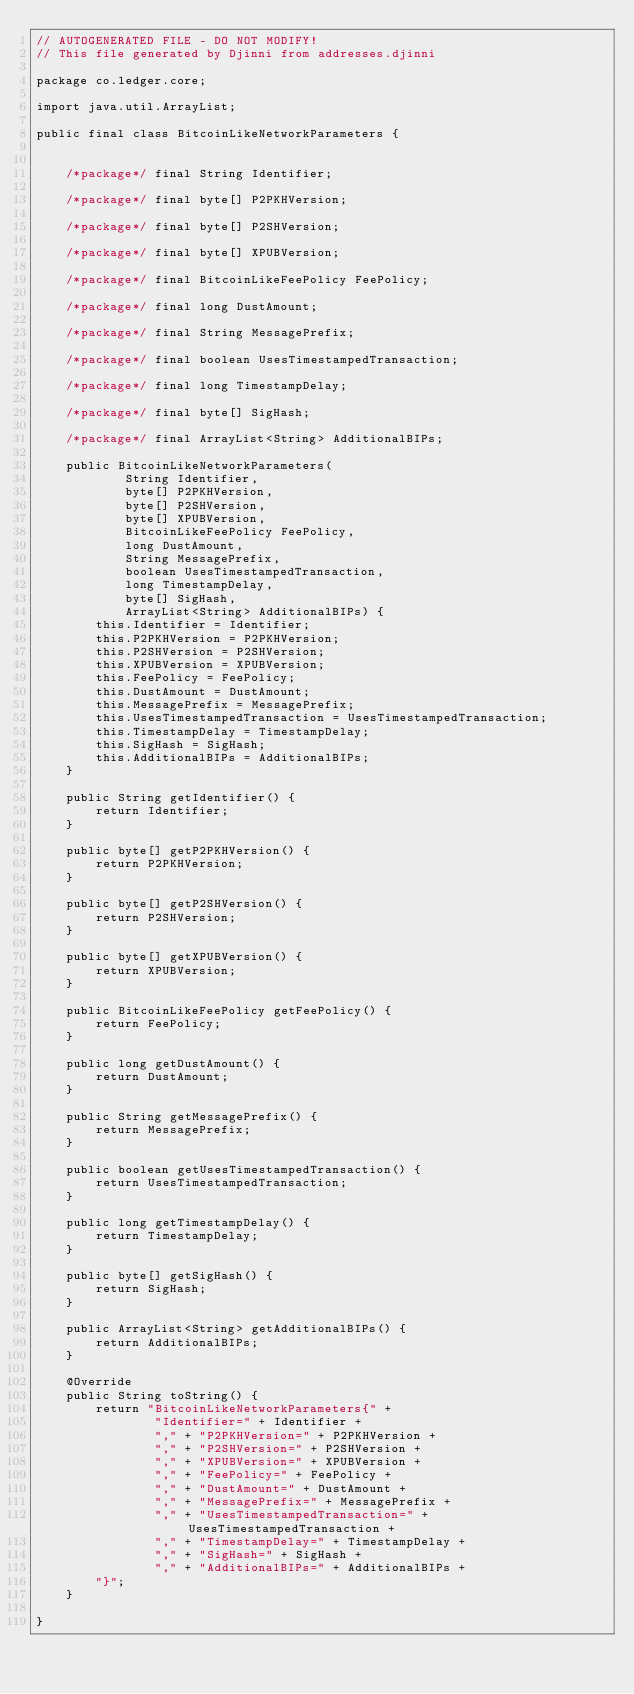Convert code to text. <code><loc_0><loc_0><loc_500><loc_500><_Java_>// AUTOGENERATED FILE - DO NOT MODIFY!
// This file generated by Djinni from addresses.djinni

package co.ledger.core;

import java.util.ArrayList;

public final class BitcoinLikeNetworkParameters {


    /*package*/ final String Identifier;

    /*package*/ final byte[] P2PKHVersion;

    /*package*/ final byte[] P2SHVersion;

    /*package*/ final byte[] XPUBVersion;

    /*package*/ final BitcoinLikeFeePolicy FeePolicy;

    /*package*/ final long DustAmount;

    /*package*/ final String MessagePrefix;

    /*package*/ final boolean UsesTimestampedTransaction;

    /*package*/ final long TimestampDelay;

    /*package*/ final byte[] SigHash;

    /*package*/ final ArrayList<String> AdditionalBIPs;

    public BitcoinLikeNetworkParameters(
            String Identifier,
            byte[] P2PKHVersion,
            byte[] P2SHVersion,
            byte[] XPUBVersion,
            BitcoinLikeFeePolicy FeePolicy,
            long DustAmount,
            String MessagePrefix,
            boolean UsesTimestampedTransaction,
            long TimestampDelay,
            byte[] SigHash,
            ArrayList<String> AdditionalBIPs) {
        this.Identifier = Identifier;
        this.P2PKHVersion = P2PKHVersion;
        this.P2SHVersion = P2SHVersion;
        this.XPUBVersion = XPUBVersion;
        this.FeePolicy = FeePolicy;
        this.DustAmount = DustAmount;
        this.MessagePrefix = MessagePrefix;
        this.UsesTimestampedTransaction = UsesTimestampedTransaction;
        this.TimestampDelay = TimestampDelay;
        this.SigHash = SigHash;
        this.AdditionalBIPs = AdditionalBIPs;
    }

    public String getIdentifier() {
        return Identifier;
    }

    public byte[] getP2PKHVersion() {
        return P2PKHVersion;
    }

    public byte[] getP2SHVersion() {
        return P2SHVersion;
    }

    public byte[] getXPUBVersion() {
        return XPUBVersion;
    }

    public BitcoinLikeFeePolicy getFeePolicy() {
        return FeePolicy;
    }

    public long getDustAmount() {
        return DustAmount;
    }

    public String getMessagePrefix() {
        return MessagePrefix;
    }

    public boolean getUsesTimestampedTransaction() {
        return UsesTimestampedTransaction;
    }

    public long getTimestampDelay() {
        return TimestampDelay;
    }

    public byte[] getSigHash() {
        return SigHash;
    }

    public ArrayList<String> getAdditionalBIPs() {
        return AdditionalBIPs;
    }

    @Override
    public String toString() {
        return "BitcoinLikeNetworkParameters{" +
                "Identifier=" + Identifier +
                "," + "P2PKHVersion=" + P2PKHVersion +
                "," + "P2SHVersion=" + P2SHVersion +
                "," + "XPUBVersion=" + XPUBVersion +
                "," + "FeePolicy=" + FeePolicy +
                "," + "DustAmount=" + DustAmount +
                "," + "MessagePrefix=" + MessagePrefix +
                "," + "UsesTimestampedTransaction=" + UsesTimestampedTransaction +
                "," + "TimestampDelay=" + TimestampDelay +
                "," + "SigHash=" + SigHash +
                "," + "AdditionalBIPs=" + AdditionalBIPs +
        "}";
    }

}
</code> 